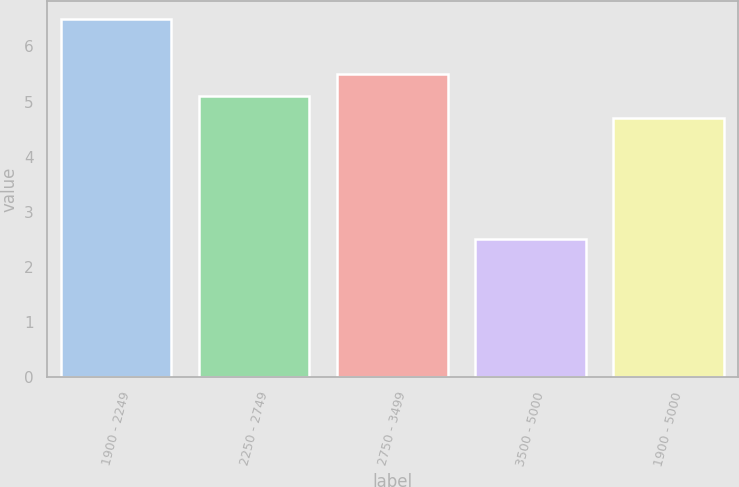<chart> <loc_0><loc_0><loc_500><loc_500><bar_chart><fcel>1900 - 2249<fcel>2250 - 2749<fcel>2750 - 3499<fcel>3500 - 5000<fcel>1900 - 5000<nl><fcel>6.5<fcel>5.1<fcel>5.5<fcel>2.5<fcel>4.7<nl></chart> 